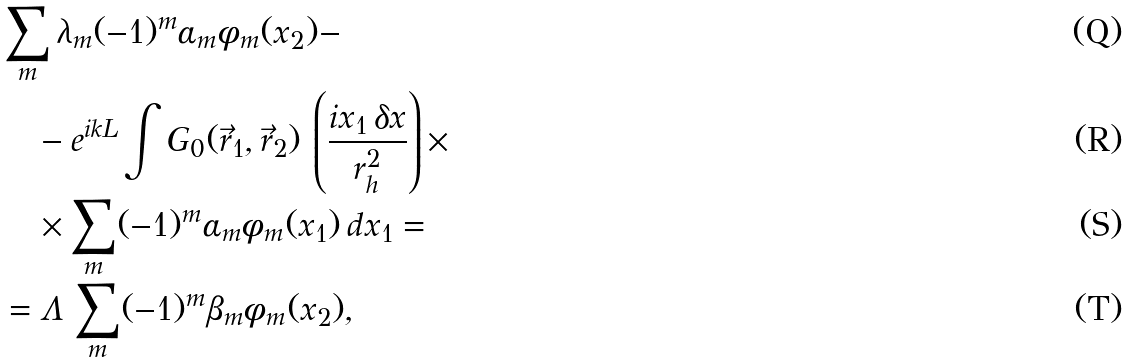<formula> <loc_0><loc_0><loc_500><loc_500>& \sum _ { m } \lambda _ { m } ( - 1 ) ^ { m } \alpha _ { m } \phi _ { m } ( x _ { 2 } ) - \\ & \quad - e ^ { i k L } \int G _ { 0 } ( \vec { r } _ { 1 } , \vec { r } _ { 2 } ) \, \left ( \frac { i x _ { 1 } \, \delta x } { r _ { h } ^ { 2 } } \right ) \times \\ & \quad \times \sum _ { m } ( - 1 ) ^ { m } \alpha _ { m } \phi _ { m } ( x _ { 1 } ) \, d x _ { 1 } = \\ & = \Lambda \, \sum _ { m } ( - 1 ) ^ { m } \beta _ { m } \phi _ { m } ( x _ { 2 } ) ,</formula> 